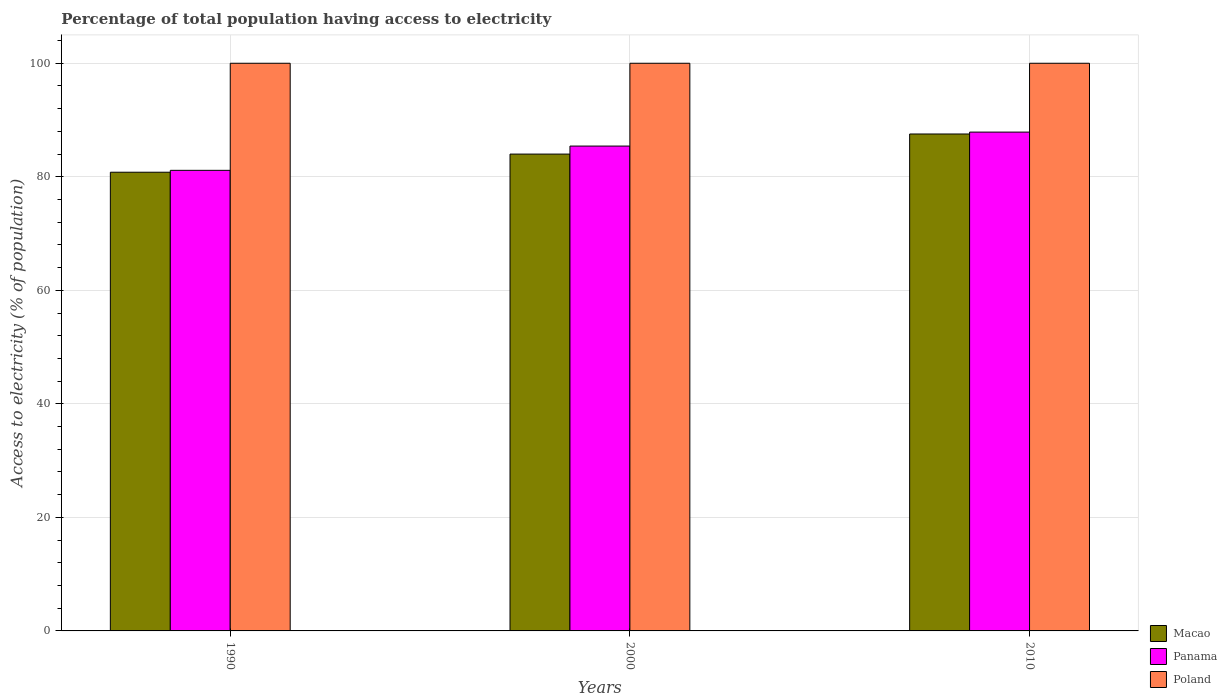How many different coloured bars are there?
Offer a terse response. 3. How many groups of bars are there?
Make the answer very short. 3. How many bars are there on the 2nd tick from the right?
Provide a succinct answer. 3. In how many cases, is the number of bars for a given year not equal to the number of legend labels?
Keep it short and to the point. 0. What is the percentage of population that have access to electricity in Panama in 2000?
Provide a succinct answer. 85.41. Across all years, what is the maximum percentage of population that have access to electricity in Poland?
Ensure brevity in your answer.  100. Across all years, what is the minimum percentage of population that have access to electricity in Macao?
Your response must be concise. 80.8. In which year was the percentage of population that have access to electricity in Poland maximum?
Provide a short and direct response. 1990. In which year was the percentage of population that have access to electricity in Macao minimum?
Keep it short and to the point. 1990. What is the total percentage of population that have access to electricity in Macao in the graph?
Your answer should be very brief. 252.34. What is the difference between the percentage of population that have access to electricity in Panama in 1990 and that in 2010?
Offer a terse response. -6.74. What is the difference between the percentage of population that have access to electricity in Macao in 2000 and the percentage of population that have access to electricity in Panama in 1990?
Make the answer very short. 2.86. In the year 2010, what is the difference between the percentage of population that have access to electricity in Macao and percentage of population that have access to electricity in Poland?
Offer a terse response. -12.46. Is the percentage of population that have access to electricity in Panama in 1990 less than that in 2010?
Make the answer very short. Yes. Is the difference between the percentage of population that have access to electricity in Macao in 2000 and 2010 greater than the difference between the percentage of population that have access to electricity in Poland in 2000 and 2010?
Offer a very short reply. No. What is the difference between the highest and the second highest percentage of population that have access to electricity in Panama?
Offer a very short reply. 2.46. What is the difference between the highest and the lowest percentage of population that have access to electricity in Poland?
Provide a short and direct response. 0. In how many years, is the percentage of population that have access to electricity in Poland greater than the average percentage of population that have access to electricity in Poland taken over all years?
Your response must be concise. 0. Is the sum of the percentage of population that have access to electricity in Panama in 2000 and 2010 greater than the maximum percentage of population that have access to electricity in Poland across all years?
Provide a succinct answer. Yes. What does the 3rd bar from the left in 1990 represents?
Offer a terse response. Poland. What does the 1st bar from the right in 1990 represents?
Your answer should be compact. Poland. Are the values on the major ticks of Y-axis written in scientific E-notation?
Your answer should be very brief. No. Does the graph contain any zero values?
Offer a very short reply. No. What is the title of the graph?
Ensure brevity in your answer.  Percentage of total population having access to electricity. Does "Middle East & North Africa (developing only)" appear as one of the legend labels in the graph?
Offer a terse response. No. What is the label or title of the Y-axis?
Offer a terse response. Access to electricity (% of population). What is the Access to electricity (% of population) in Macao in 1990?
Your answer should be compact. 80.8. What is the Access to electricity (% of population) in Panama in 1990?
Provide a short and direct response. 81.14. What is the Access to electricity (% of population) in Poland in 1990?
Your response must be concise. 100. What is the Access to electricity (% of population) of Panama in 2000?
Offer a very short reply. 85.41. What is the Access to electricity (% of population) in Poland in 2000?
Your answer should be compact. 100. What is the Access to electricity (% of population) in Macao in 2010?
Ensure brevity in your answer.  87.54. What is the Access to electricity (% of population) of Panama in 2010?
Offer a very short reply. 87.87. What is the Access to electricity (% of population) of Poland in 2010?
Your response must be concise. 100. Across all years, what is the maximum Access to electricity (% of population) of Macao?
Keep it short and to the point. 87.54. Across all years, what is the maximum Access to electricity (% of population) of Panama?
Offer a terse response. 87.87. Across all years, what is the maximum Access to electricity (% of population) of Poland?
Your answer should be very brief. 100. Across all years, what is the minimum Access to electricity (% of population) of Macao?
Offer a terse response. 80.8. Across all years, what is the minimum Access to electricity (% of population) of Panama?
Offer a terse response. 81.14. Across all years, what is the minimum Access to electricity (% of population) of Poland?
Give a very brief answer. 100. What is the total Access to electricity (% of population) of Macao in the graph?
Offer a very short reply. 252.34. What is the total Access to electricity (% of population) in Panama in the graph?
Your answer should be very brief. 254.42. What is the total Access to electricity (% of population) in Poland in the graph?
Make the answer very short. 300. What is the difference between the Access to electricity (% of population) of Macao in 1990 and that in 2000?
Keep it short and to the point. -3.2. What is the difference between the Access to electricity (% of population) in Panama in 1990 and that in 2000?
Your response must be concise. -4.28. What is the difference between the Access to electricity (% of population) of Poland in 1990 and that in 2000?
Make the answer very short. 0. What is the difference between the Access to electricity (% of population) in Macao in 1990 and that in 2010?
Provide a short and direct response. -6.74. What is the difference between the Access to electricity (% of population) of Panama in 1990 and that in 2010?
Give a very brief answer. -6.74. What is the difference between the Access to electricity (% of population) in Poland in 1990 and that in 2010?
Your answer should be compact. 0. What is the difference between the Access to electricity (% of population) in Macao in 2000 and that in 2010?
Offer a very short reply. -3.54. What is the difference between the Access to electricity (% of population) in Panama in 2000 and that in 2010?
Ensure brevity in your answer.  -2.46. What is the difference between the Access to electricity (% of population) in Macao in 1990 and the Access to electricity (% of population) in Panama in 2000?
Give a very brief answer. -4.61. What is the difference between the Access to electricity (% of population) in Macao in 1990 and the Access to electricity (% of population) in Poland in 2000?
Ensure brevity in your answer.  -19.2. What is the difference between the Access to electricity (% of population) in Panama in 1990 and the Access to electricity (% of population) in Poland in 2000?
Offer a terse response. -18.86. What is the difference between the Access to electricity (% of population) in Macao in 1990 and the Access to electricity (% of population) in Panama in 2010?
Ensure brevity in your answer.  -7.07. What is the difference between the Access to electricity (% of population) of Macao in 1990 and the Access to electricity (% of population) of Poland in 2010?
Offer a very short reply. -19.2. What is the difference between the Access to electricity (% of population) of Panama in 1990 and the Access to electricity (% of population) of Poland in 2010?
Your answer should be very brief. -18.86. What is the difference between the Access to electricity (% of population) in Macao in 2000 and the Access to electricity (% of population) in Panama in 2010?
Your answer should be compact. -3.87. What is the difference between the Access to electricity (% of population) in Panama in 2000 and the Access to electricity (% of population) in Poland in 2010?
Provide a short and direct response. -14.59. What is the average Access to electricity (% of population) of Macao per year?
Give a very brief answer. 84.11. What is the average Access to electricity (% of population) of Panama per year?
Keep it short and to the point. 84.81. In the year 1990, what is the difference between the Access to electricity (% of population) in Macao and Access to electricity (% of population) in Panama?
Your response must be concise. -0.33. In the year 1990, what is the difference between the Access to electricity (% of population) in Macao and Access to electricity (% of population) in Poland?
Provide a short and direct response. -19.2. In the year 1990, what is the difference between the Access to electricity (% of population) in Panama and Access to electricity (% of population) in Poland?
Keep it short and to the point. -18.86. In the year 2000, what is the difference between the Access to electricity (% of population) of Macao and Access to electricity (% of population) of Panama?
Provide a succinct answer. -1.41. In the year 2000, what is the difference between the Access to electricity (% of population) of Panama and Access to electricity (% of population) of Poland?
Give a very brief answer. -14.59. In the year 2010, what is the difference between the Access to electricity (% of population) of Macao and Access to electricity (% of population) of Panama?
Your answer should be compact. -0.33. In the year 2010, what is the difference between the Access to electricity (% of population) of Macao and Access to electricity (% of population) of Poland?
Give a very brief answer. -12.46. In the year 2010, what is the difference between the Access to electricity (% of population) in Panama and Access to electricity (% of population) in Poland?
Your response must be concise. -12.13. What is the ratio of the Access to electricity (% of population) of Macao in 1990 to that in 2000?
Provide a short and direct response. 0.96. What is the ratio of the Access to electricity (% of population) in Panama in 1990 to that in 2000?
Your response must be concise. 0.95. What is the ratio of the Access to electricity (% of population) of Poland in 1990 to that in 2000?
Provide a succinct answer. 1. What is the ratio of the Access to electricity (% of population) in Macao in 1990 to that in 2010?
Keep it short and to the point. 0.92. What is the ratio of the Access to electricity (% of population) in Panama in 1990 to that in 2010?
Your answer should be compact. 0.92. What is the ratio of the Access to electricity (% of population) of Poland in 1990 to that in 2010?
Ensure brevity in your answer.  1. What is the ratio of the Access to electricity (% of population) of Macao in 2000 to that in 2010?
Offer a very short reply. 0.96. What is the ratio of the Access to electricity (% of population) of Poland in 2000 to that in 2010?
Your response must be concise. 1. What is the difference between the highest and the second highest Access to electricity (% of population) in Macao?
Your answer should be compact. 3.54. What is the difference between the highest and the second highest Access to electricity (% of population) in Panama?
Offer a terse response. 2.46. What is the difference between the highest and the lowest Access to electricity (% of population) in Macao?
Offer a very short reply. 6.74. What is the difference between the highest and the lowest Access to electricity (% of population) in Panama?
Offer a terse response. 6.74. What is the difference between the highest and the lowest Access to electricity (% of population) of Poland?
Your answer should be very brief. 0. 